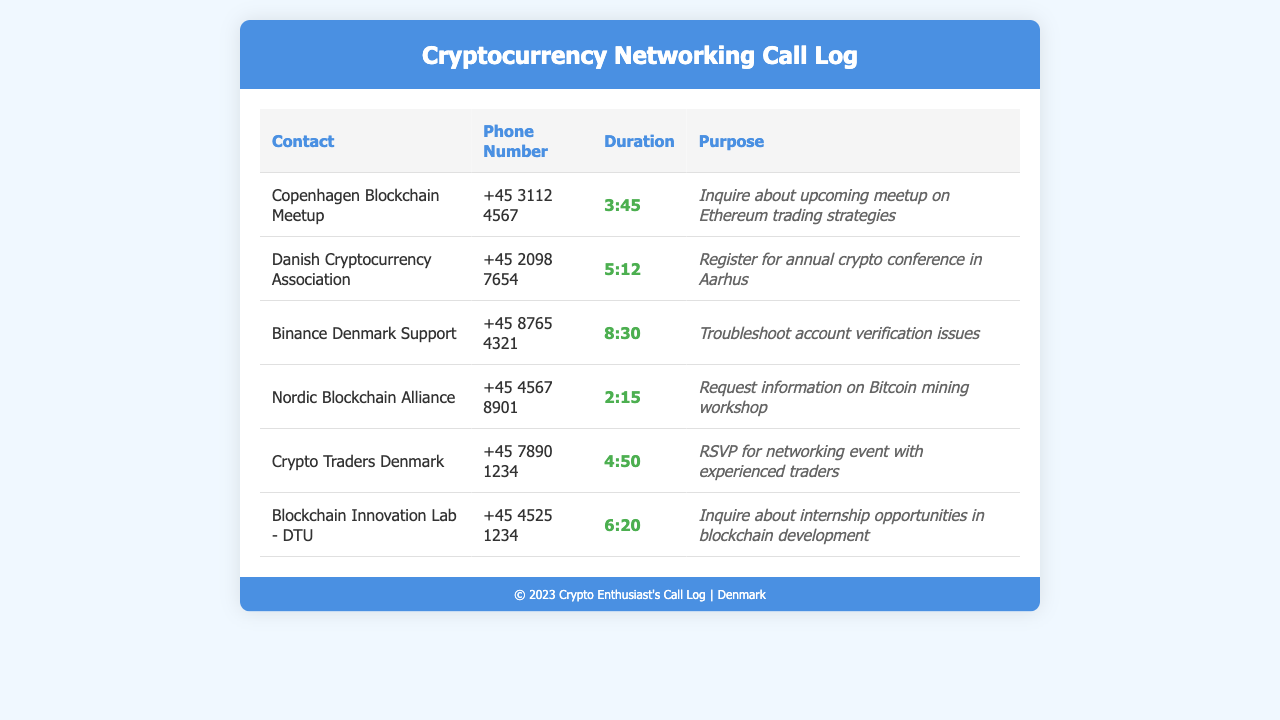What is the duration of the call to the Copenhagen Blockchain Meetup? The duration is the time spent on the call, which is listed as 3 minutes and 45 seconds.
Answer: 3:45 What is the purpose of the call to the Danish Cryptocurrency Association? The purpose indicates that the caller registered for an annual crypto conference in Aarhus.
Answer: Register for annual crypto conference in Aarhus How long was the call to Binance Denmark Support? This is found by checking the duration listed which indicates the length of the conversation.
Answer: 8:30 Which organization was contacted to request information on a Bitcoin mining workshop? The relevant organization is mentioned in the purpose of the call, indicating which entity was sought for information.
Answer: Nordic Blockchain Alliance What is the phone number for Crypto Traders Denmark? The phone number associated with Crypto Traders Denmark can be retrieved from the table under the phone number column.
Answer: +45 7890 1234 Which meetup was inquired about regarding Ethereum trading strategies? The document lists the purpose of the call, indicating this specific meetup related to Ethereum.
Answer: Copenhagen Blockchain Meetup How many calls were made regarding networking events? This can be calculated by reviewing the purposes of the relevant calls for networking events.
Answer: 2 What is the duration of the call to Blockchain Innovation Lab - DTU? The answer is contained directly within the entry for the call, revealing the time of the call.
Answer: 6:20 Which organization was called to RSVP for a networking event with experienced traders? The specific organization can be identified from the entry detailing the RSVP purpose.
Answer: Crypto Traders Denmark 